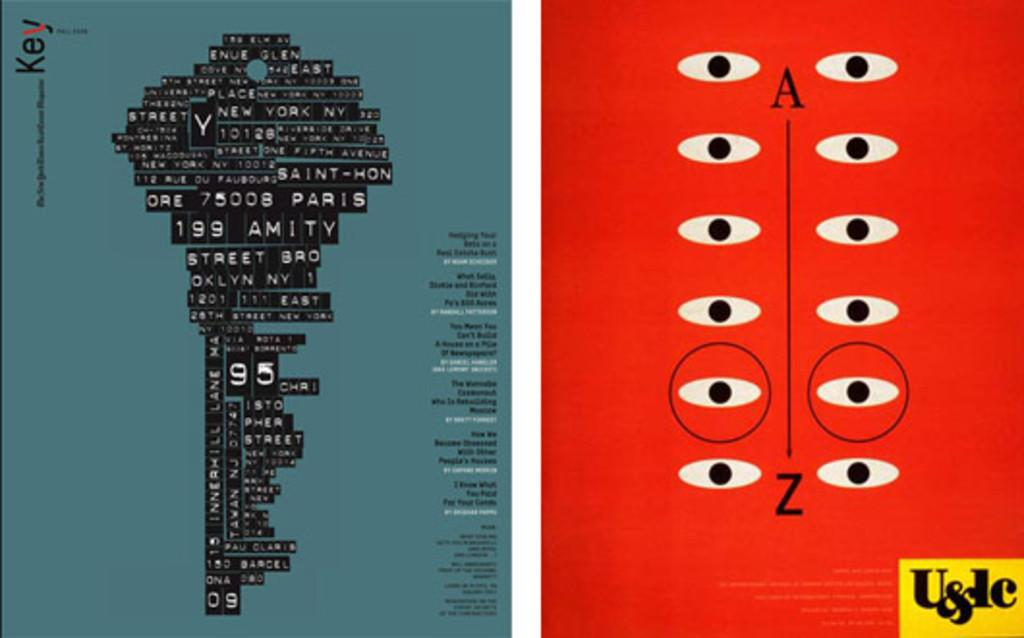What is the main subject of the image? The main subject is an animated key. How is the key created? The key is created using text. How many tin balls are present in the image? There are no tin balls present in the image. 